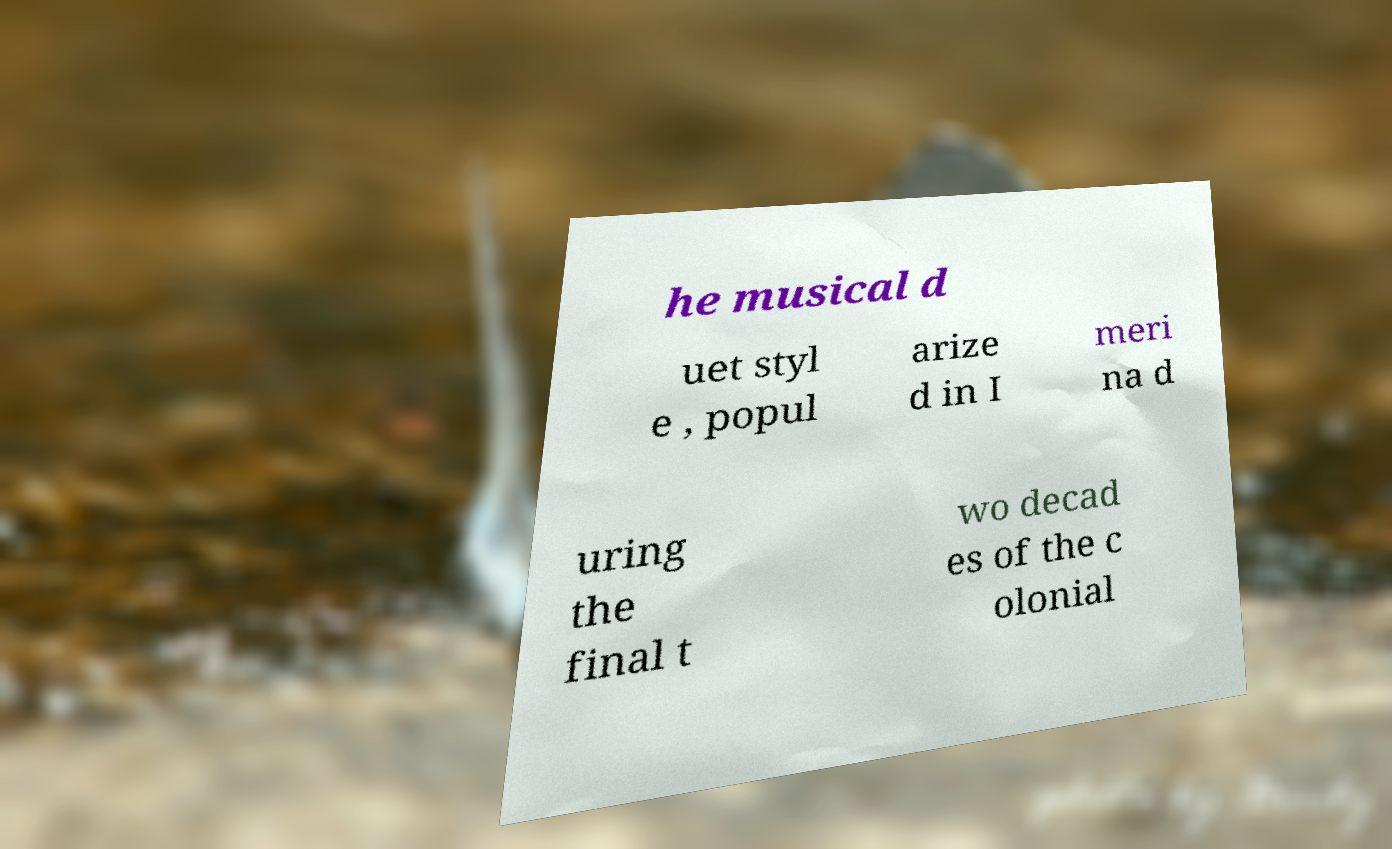Can you accurately transcribe the text from the provided image for me? he musical d uet styl e , popul arize d in I meri na d uring the final t wo decad es of the c olonial 